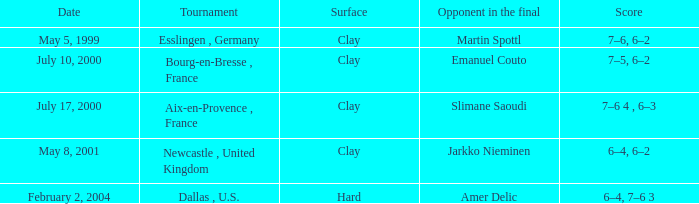What is the Score of the Tournament played on Clay Surface on May 5, 1999? 7–6, 6–2. 